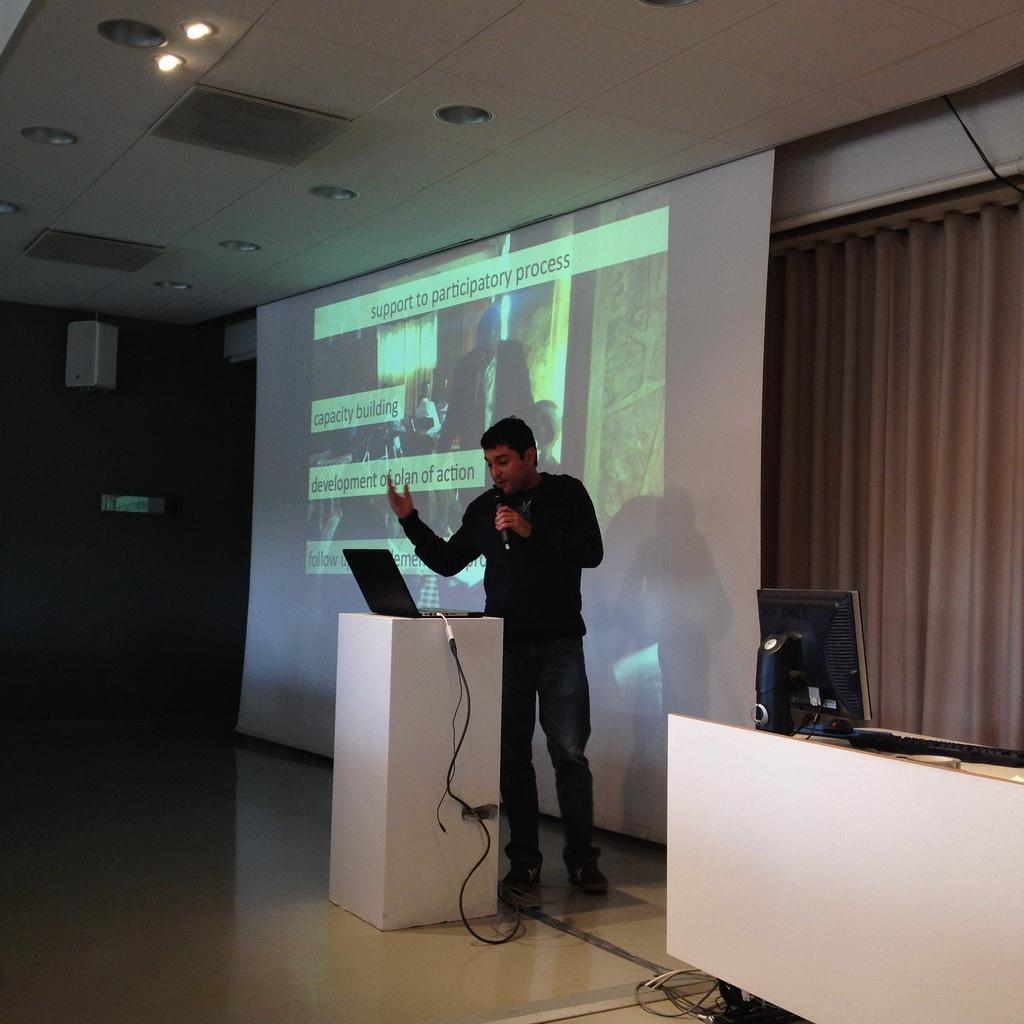<image>
Relay a brief, clear account of the picture shown. The screen has a slide that is titled, "support to participatory process." 